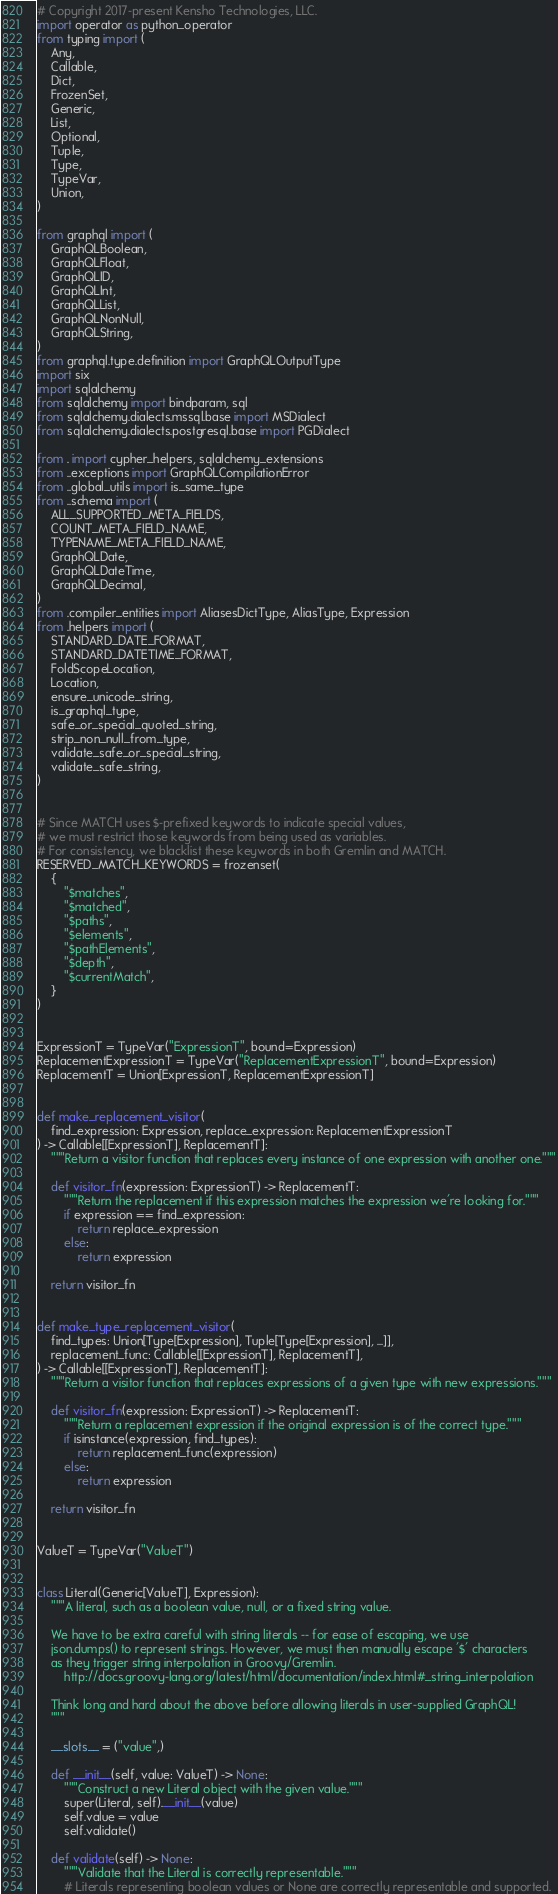Convert code to text. <code><loc_0><loc_0><loc_500><loc_500><_Python_># Copyright 2017-present Kensho Technologies, LLC.
import operator as python_operator
from typing import (
    Any,
    Callable,
    Dict,
    FrozenSet,
    Generic,
    List,
    Optional,
    Tuple,
    Type,
    TypeVar,
    Union,
)

from graphql import (
    GraphQLBoolean,
    GraphQLFloat,
    GraphQLID,
    GraphQLInt,
    GraphQLList,
    GraphQLNonNull,
    GraphQLString,
)
from graphql.type.definition import GraphQLOutputType
import six
import sqlalchemy
from sqlalchemy import bindparam, sql
from sqlalchemy.dialects.mssql.base import MSDialect
from sqlalchemy.dialects.postgresql.base import PGDialect

from . import cypher_helpers, sqlalchemy_extensions
from ..exceptions import GraphQLCompilationError
from ..global_utils import is_same_type
from ..schema import (
    ALL_SUPPORTED_META_FIELDS,
    COUNT_META_FIELD_NAME,
    TYPENAME_META_FIELD_NAME,
    GraphQLDate,
    GraphQLDateTime,
    GraphQLDecimal,
)
from .compiler_entities import AliasesDictType, AliasType, Expression
from .helpers import (
    STANDARD_DATE_FORMAT,
    STANDARD_DATETIME_FORMAT,
    FoldScopeLocation,
    Location,
    ensure_unicode_string,
    is_graphql_type,
    safe_or_special_quoted_string,
    strip_non_null_from_type,
    validate_safe_or_special_string,
    validate_safe_string,
)


# Since MATCH uses $-prefixed keywords to indicate special values,
# we must restrict those keywords from being used as variables.
# For consistency, we blacklist these keywords in both Gremlin and MATCH.
RESERVED_MATCH_KEYWORDS = frozenset(
    {
        "$matches",
        "$matched",
        "$paths",
        "$elements",
        "$pathElements",
        "$depth",
        "$currentMatch",
    }
)


ExpressionT = TypeVar("ExpressionT", bound=Expression)
ReplacementExpressionT = TypeVar("ReplacementExpressionT", bound=Expression)
ReplacementT = Union[ExpressionT, ReplacementExpressionT]


def make_replacement_visitor(
    find_expression: Expression, replace_expression: ReplacementExpressionT
) -> Callable[[ExpressionT], ReplacementT]:
    """Return a visitor function that replaces every instance of one expression with another one."""

    def visitor_fn(expression: ExpressionT) -> ReplacementT:
        """Return the replacement if this expression matches the expression we're looking for."""
        if expression == find_expression:
            return replace_expression
        else:
            return expression

    return visitor_fn


def make_type_replacement_visitor(
    find_types: Union[Type[Expression], Tuple[Type[Expression], ...]],
    replacement_func: Callable[[ExpressionT], ReplacementT],
) -> Callable[[ExpressionT], ReplacementT]:
    """Return a visitor function that replaces expressions of a given type with new expressions."""

    def visitor_fn(expression: ExpressionT) -> ReplacementT:
        """Return a replacement expression if the original expression is of the correct type."""
        if isinstance(expression, find_types):
            return replacement_func(expression)
        else:
            return expression

    return visitor_fn


ValueT = TypeVar("ValueT")


class Literal(Generic[ValueT], Expression):
    """A literal, such as a boolean value, null, or a fixed string value.

    We have to be extra careful with string literals -- for ease of escaping, we use
    json.dumps() to represent strings. However, we must then manually escape '$' characters
    as they trigger string interpolation in Groovy/Gremlin.
        http://docs.groovy-lang.org/latest/html/documentation/index.html#_string_interpolation

    Think long and hard about the above before allowing literals in user-supplied GraphQL!
    """

    __slots__ = ("value",)

    def __init__(self, value: ValueT) -> None:
        """Construct a new Literal object with the given value."""
        super(Literal, self).__init__(value)
        self.value = value
        self.validate()

    def validate(self) -> None:
        """Validate that the Literal is correctly representable."""
        # Literals representing boolean values or None are correctly representable and supported.</code> 